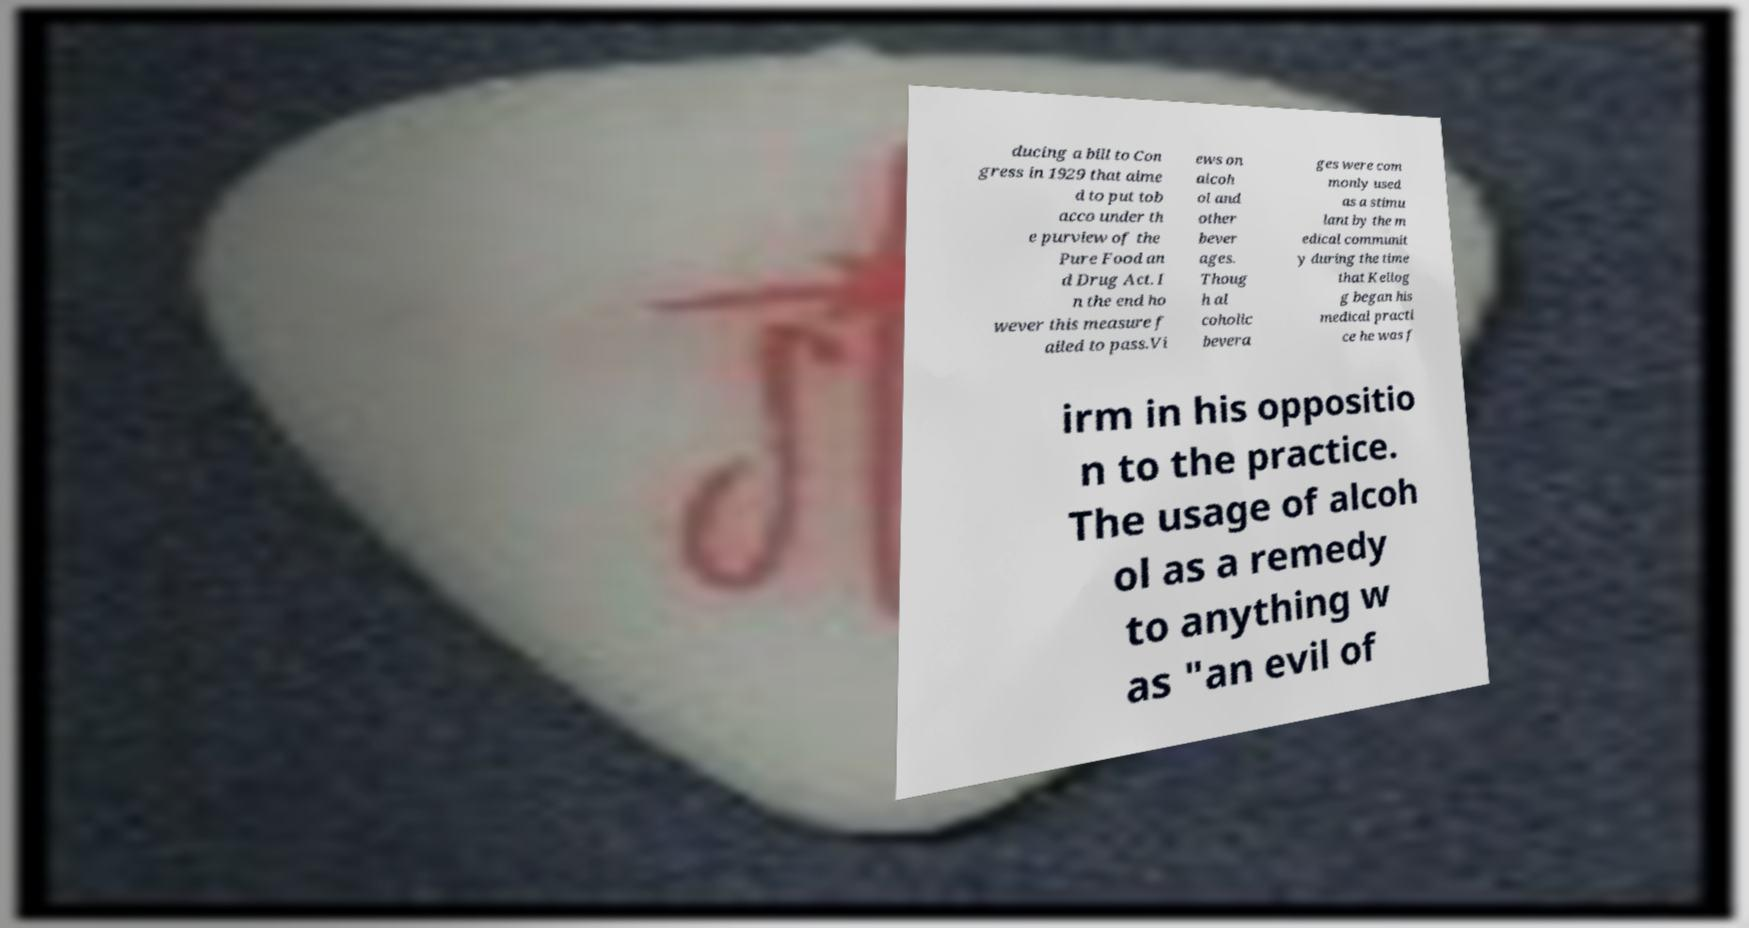I need the written content from this picture converted into text. Can you do that? ducing a bill to Con gress in 1929 that aime d to put tob acco under th e purview of the Pure Food an d Drug Act. I n the end ho wever this measure f ailed to pass.Vi ews on alcoh ol and other bever ages. Thoug h al coholic bevera ges were com monly used as a stimu lant by the m edical communit y during the time that Kellog g began his medical practi ce he was f irm in his oppositio n to the practice. The usage of alcoh ol as a remedy to anything w as "an evil of 